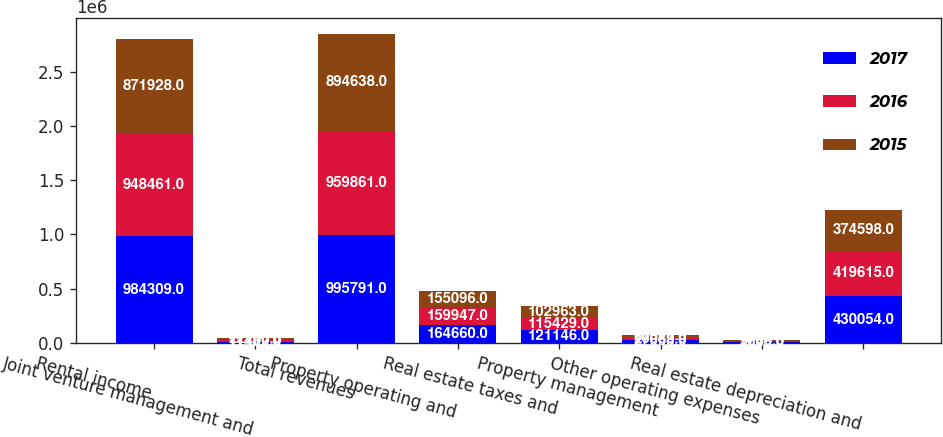Convert chart to OTSL. <chart><loc_0><loc_0><loc_500><loc_500><stacked_bar_chart><ecel><fcel>Rental income<fcel>Joint venture management and<fcel>Total revenues<fcel>Property operating and<fcel>Real estate taxes and<fcel>Property management<fcel>Other operating expenses<fcel>Real estate depreciation and<nl><fcel>2017<fcel>984309<fcel>11482<fcel>995791<fcel>164660<fcel>121146<fcel>27068<fcel>9060<fcel>430054<nl><fcel>2016<fcel>948461<fcel>11400<fcel>959861<fcel>159947<fcel>115429<fcel>26083<fcel>7649<fcel>419615<nl><fcel>2015<fcel>871928<fcel>22710<fcel>894638<fcel>155096<fcel>102963<fcel>23978<fcel>9708<fcel>374598<nl></chart> 